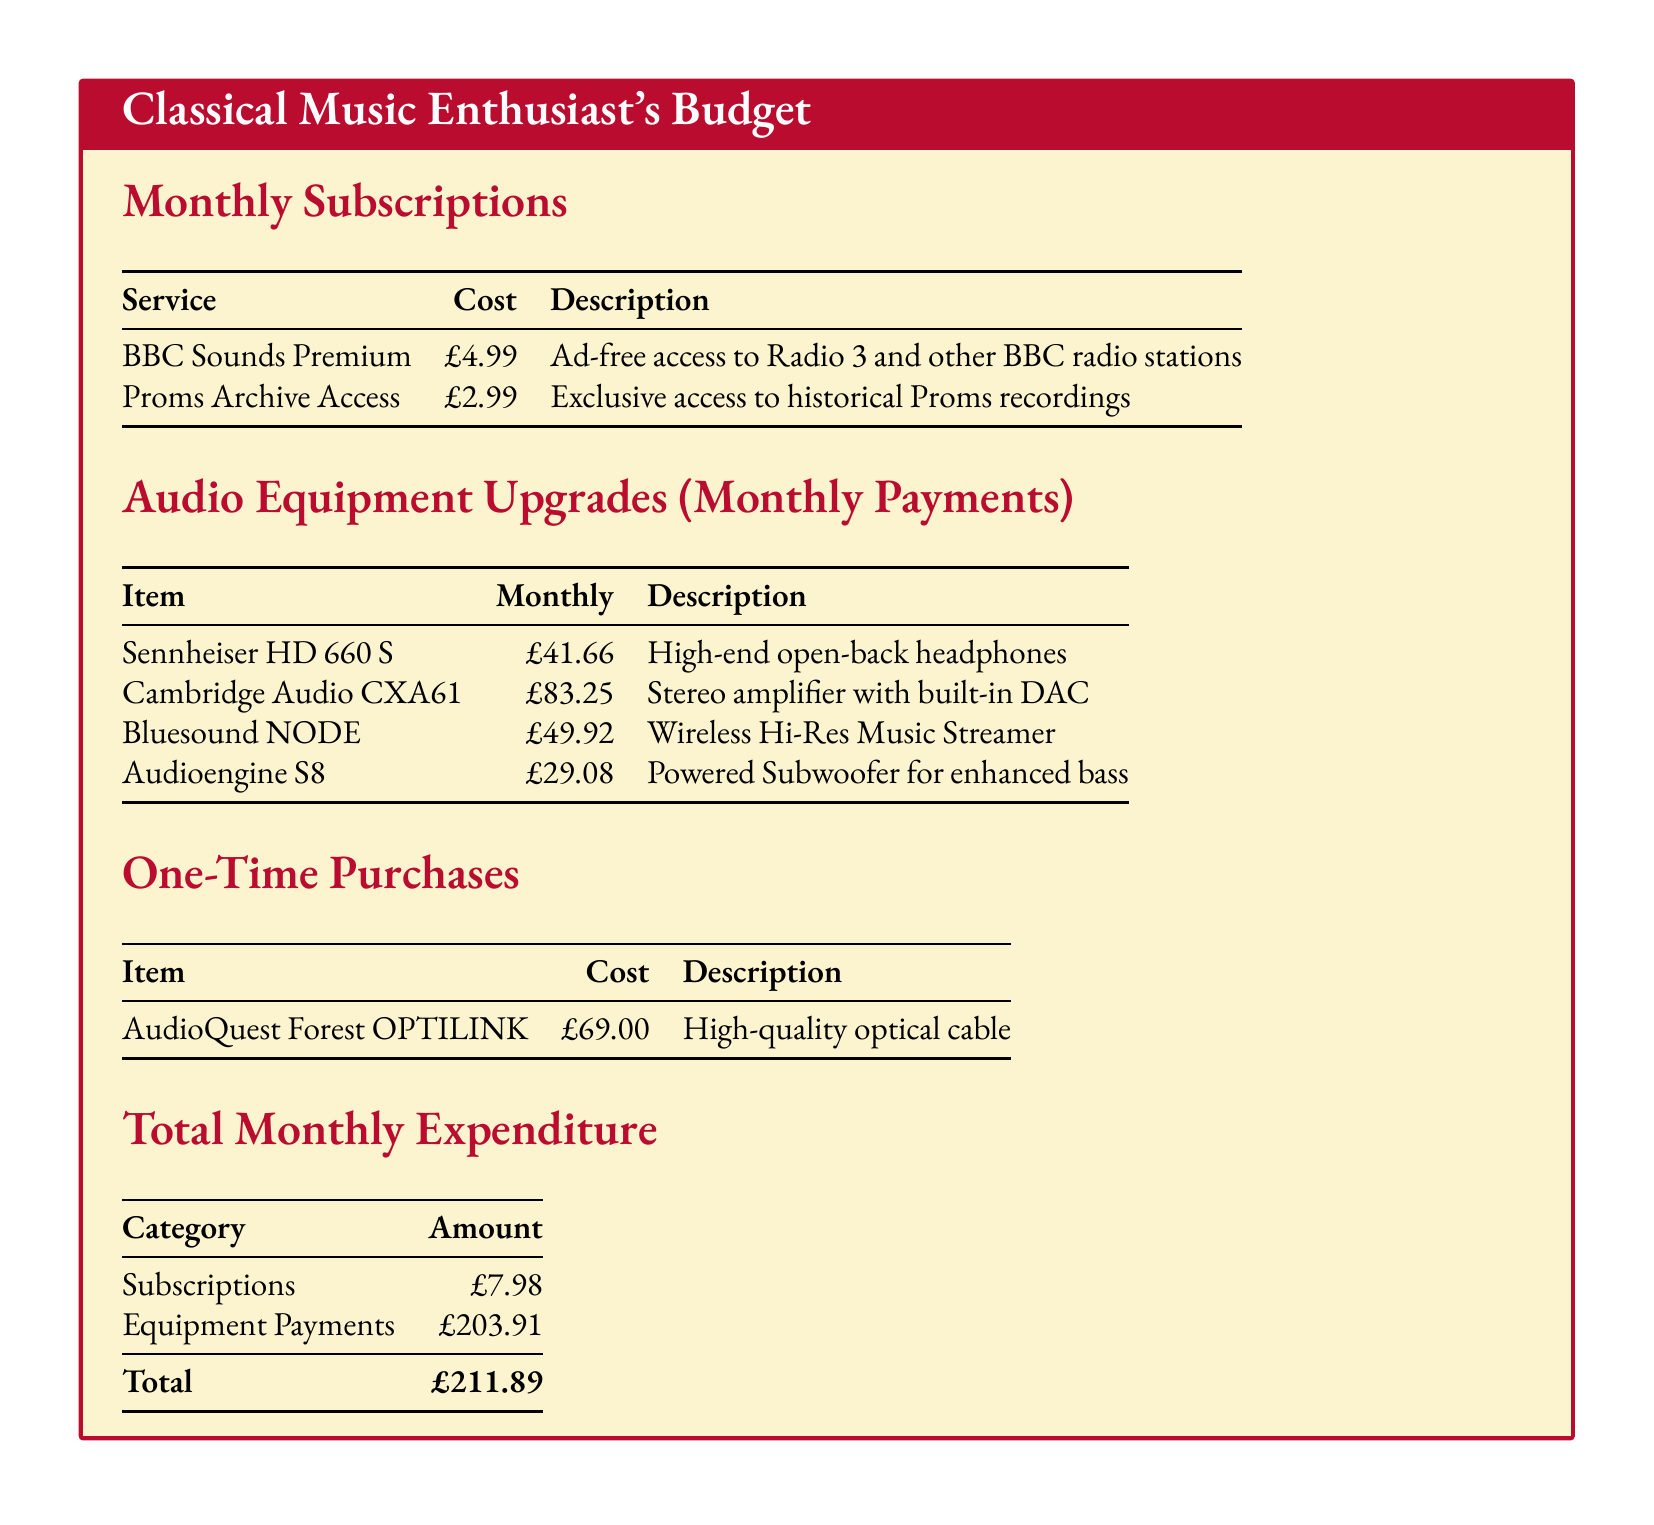what is the total monthly expenditure? The total monthly expenditure is calculated by adding subscriptions and equipment payments, which equals £7.98 + £203.91.
Answer: £211.89 how much does the BBC Sounds Premium service cost? The cost of the BBC Sounds Premium service is listed in the subscriptions section.
Answer: £4.99 what is the monthly payment for the Bluesound NODE? The monthly payment for the Bluesound NODE is mentioned under audio equipment upgrades.
Answer: £49.92 how much is spent monthly on audio equipment payments? The total amount for audio equipment payments is given in the total expenditure table, which includes all related items.
Answer: £203.91 what is the cost of the one-time purchase for the AudioQuest Forest OPTILINK? The cost of the one-time purchase is specified in the one-time purchases section.
Answer: £69.00 how much does the Cambridge Audio CXA61 cost per month? The document lists the monthly payment for the Cambridge Audio CXA61 as part of the audio equipment upgrades.
Answer: £83.25 how many services are listed under Monthly Subscriptions? The number of services can be counted in the Monthly Subscriptions section of the document.
Answer: 2 what type of headphones is the Sennheiser HD 660 S? The description for the Sennheiser HD 660 S indicates its type in the audio equipment upgrades section.
Answer: Open-back what is the total cost of subscriptions? The total cost is derived from the subscriptions listed, which are summed together.
Answer: £7.98 